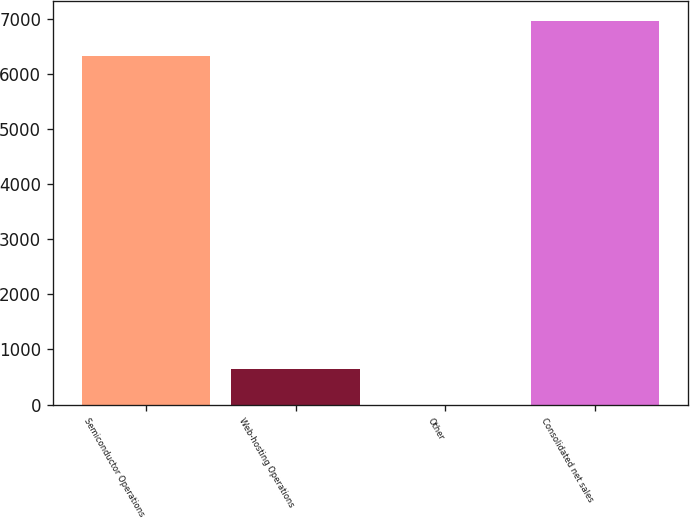<chart> <loc_0><loc_0><loc_500><loc_500><bar_chart><fcel>Semiconductor Operations<fcel>Web-hosting Operations<fcel>Other<fcel>Consolidated net sales<nl><fcel>6329.7<fcel>636.42<fcel>0.2<fcel>6965.92<nl></chart> 